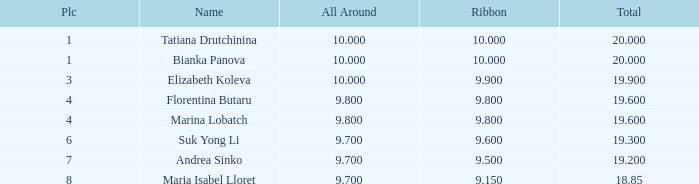What place had a ribbon below 9.8 and a 19.2 total? 7.0. 